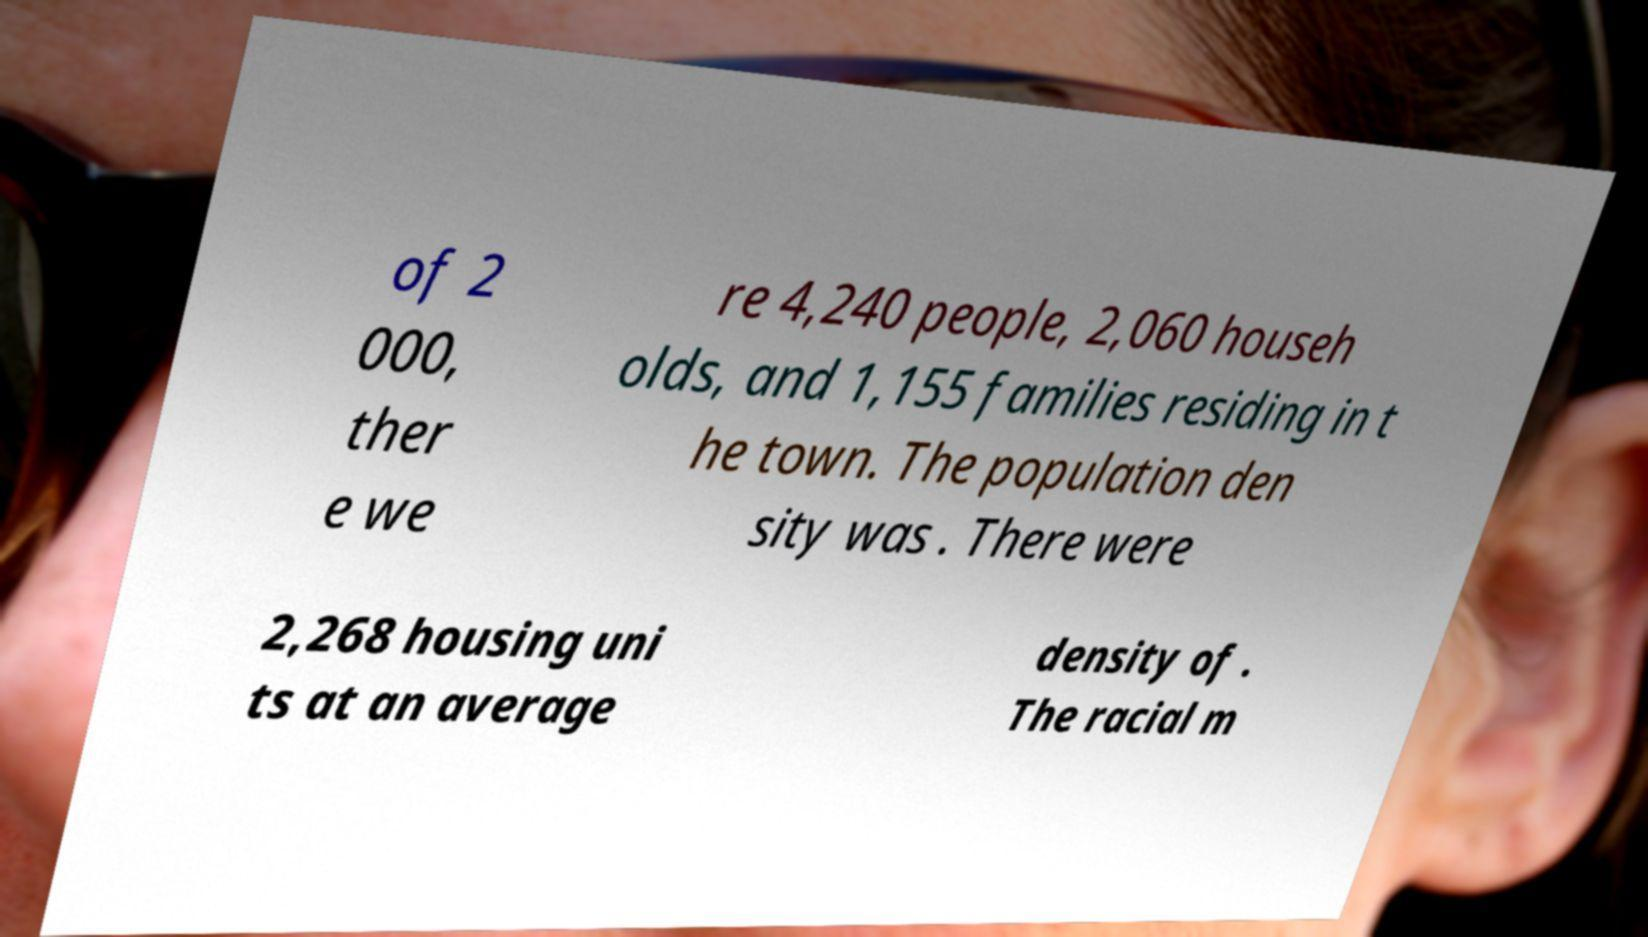There's text embedded in this image that I need extracted. Can you transcribe it verbatim? of 2 000, ther e we re 4,240 people, 2,060 househ olds, and 1,155 families residing in t he town. The population den sity was . There were 2,268 housing uni ts at an average density of . The racial m 